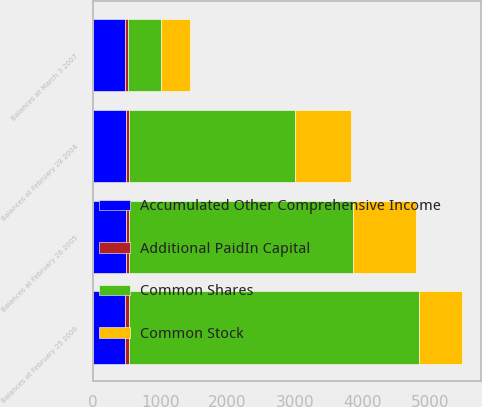Convert chart. <chart><loc_0><loc_0><loc_500><loc_500><stacked_bar_chart><ecel><fcel>Balances at February 28 2004<fcel>Balances at February 26 2005<fcel>Balances at February 25 2006<fcel>Balances at March 3 2007<nl><fcel>Accumulated Other Comprehensive Income<fcel>487<fcel>493<fcel>485<fcel>481<nl><fcel>Additional PaidIn Capital<fcel>49<fcel>49<fcel>49<fcel>48<nl><fcel>Common Stock<fcel>819<fcel>936<fcel>643<fcel>430<nl><fcel>Common Shares<fcel>2468<fcel>3315<fcel>4304<fcel>487<nl></chart> 